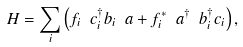<formula> <loc_0><loc_0><loc_500><loc_500>H = \sum _ { i } \left ( f _ { i } \ c _ { i } ^ { \dagger } b _ { i } \ a + f _ { i } ^ { \ast } \ a ^ { \dagger } \ b _ { i } ^ { \dagger } c _ { i } \right ) ,</formula> 